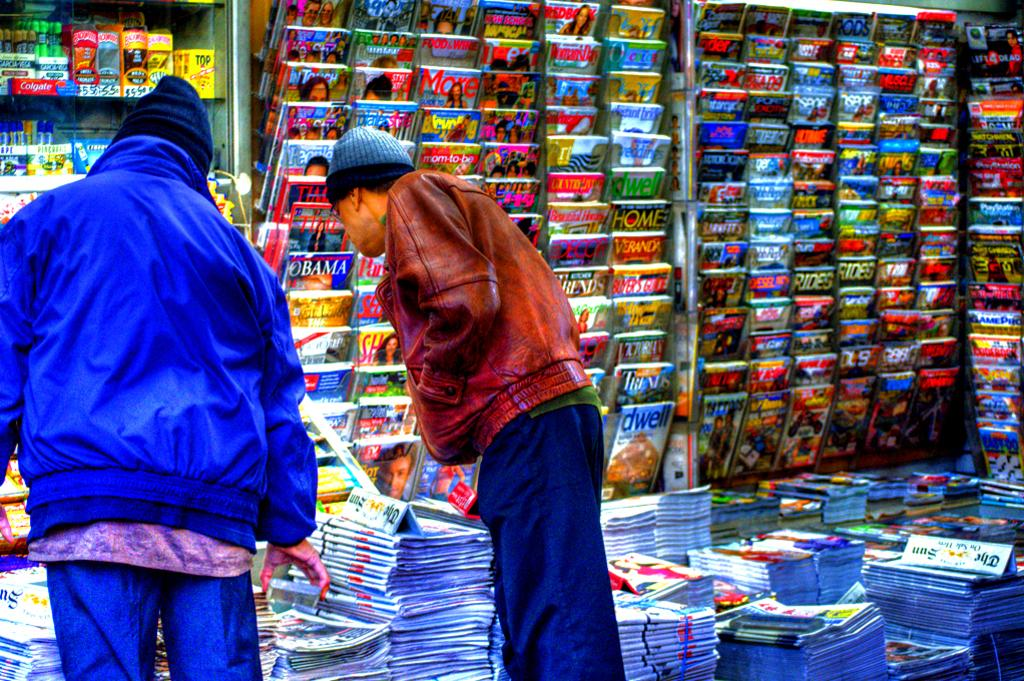Provide a one-sentence caption for the provided image. A newspaper stand with two customers browsing, the Sun is a newspaper that is for sale. 